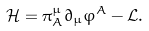<formula> <loc_0><loc_0><loc_500><loc_500>\mathcal { H } = \pi ^ { \mu } _ { A } \partial _ { \mu } \varphi ^ { A } - \mathcal { L } .</formula> 